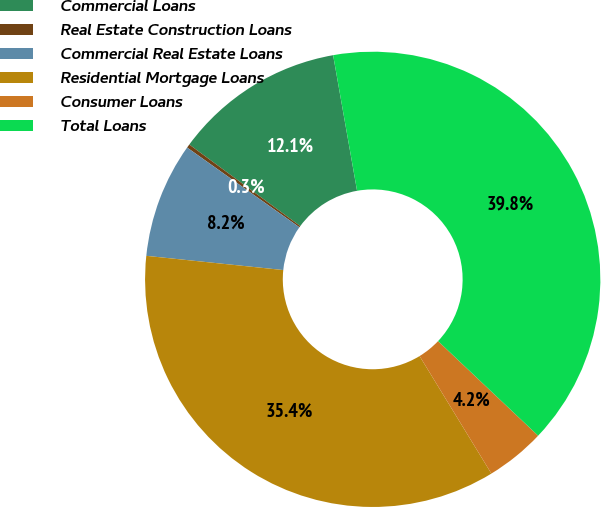Convert chart. <chart><loc_0><loc_0><loc_500><loc_500><pie_chart><fcel>Commercial Loans<fcel>Real Estate Construction Loans<fcel>Commercial Real Estate Loans<fcel>Residential Mortgage Loans<fcel>Consumer Loans<fcel>Total Loans<nl><fcel>12.13%<fcel>0.26%<fcel>8.18%<fcel>35.37%<fcel>4.22%<fcel>39.83%<nl></chart> 